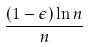Convert formula to latex. <formula><loc_0><loc_0><loc_500><loc_500>\frac { ( 1 - \epsilon ) \ln n } { n }</formula> 